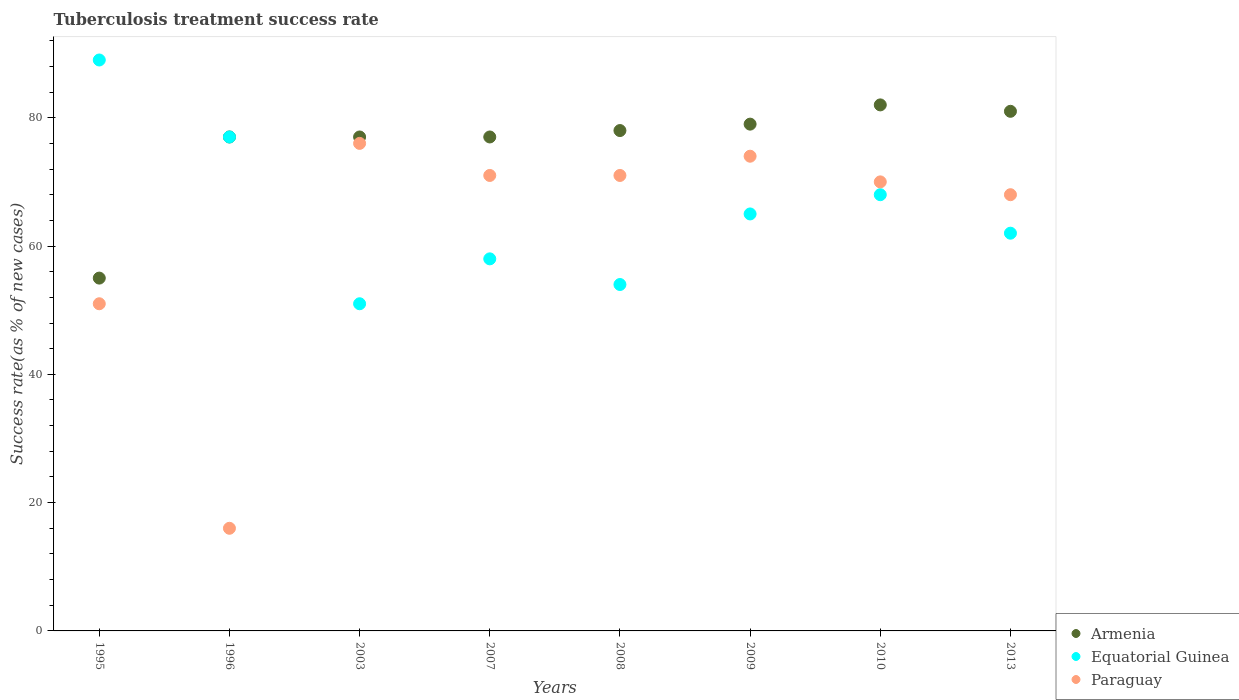How many different coloured dotlines are there?
Your response must be concise. 3. What is the tuberculosis treatment success rate in Paraguay in 2010?
Provide a succinct answer. 70. Across all years, what is the maximum tuberculosis treatment success rate in Armenia?
Your answer should be compact. 82. What is the total tuberculosis treatment success rate in Equatorial Guinea in the graph?
Your answer should be very brief. 524. What is the difference between the tuberculosis treatment success rate in Paraguay in 2003 and the tuberculosis treatment success rate in Equatorial Guinea in 1996?
Keep it short and to the point. -1. What is the average tuberculosis treatment success rate in Paraguay per year?
Provide a succinct answer. 62.12. What is the ratio of the tuberculosis treatment success rate in Equatorial Guinea in 2008 to that in 2009?
Provide a short and direct response. 0.83. Is the tuberculosis treatment success rate in Paraguay in 1996 less than that in 2008?
Ensure brevity in your answer.  Yes. Is the difference between the tuberculosis treatment success rate in Equatorial Guinea in 2008 and 2009 greater than the difference between the tuberculosis treatment success rate in Paraguay in 2008 and 2009?
Provide a short and direct response. No. What is the difference between the highest and the lowest tuberculosis treatment success rate in Paraguay?
Offer a terse response. 60. Is the sum of the tuberculosis treatment success rate in Equatorial Guinea in 1995 and 2008 greater than the maximum tuberculosis treatment success rate in Armenia across all years?
Provide a succinct answer. Yes. Does the tuberculosis treatment success rate in Paraguay monotonically increase over the years?
Give a very brief answer. No. How many dotlines are there?
Ensure brevity in your answer.  3. How many years are there in the graph?
Offer a very short reply. 8. What is the difference between two consecutive major ticks on the Y-axis?
Your answer should be compact. 20. Where does the legend appear in the graph?
Your answer should be very brief. Bottom right. How are the legend labels stacked?
Provide a succinct answer. Vertical. What is the title of the graph?
Your answer should be very brief. Tuberculosis treatment success rate. What is the label or title of the X-axis?
Ensure brevity in your answer.  Years. What is the label or title of the Y-axis?
Your answer should be compact. Success rate(as % of new cases). What is the Success rate(as % of new cases) of Armenia in 1995?
Your answer should be compact. 55. What is the Success rate(as % of new cases) of Equatorial Guinea in 1995?
Your answer should be compact. 89. What is the Success rate(as % of new cases) of Paraguay in 1995?
Your answer should be compact. 51. What is the Success rate(as % of new cases) in Equatorial Guinea in 2003?
Make the answer very short. 51. What is the Success rate(as % of new cases) in Armenia in 2007?
Keep it short and to the point. 77. What is the Success rate(as % of new cases) of Equatorial Guinea in 2007?
Make the answer very short. 58. What is the Success rate(as % of new cases) of Paraguay in 2007?
Your answer should be very brief. 71. What is the Success rate(as % of new cases) of Armenia in 2008?
Your answer should be compact. 78. What is the Success rate(as % of new cases) of Equatorial Guinea in 2008?
Your answer should be compact. 54. What is the Success rate(as % of new cases) of Paraguay in 2008?
Make the answer very short. 71. What is the Success rate(as % of new cases) in Armenia in 2009?
Provide a short and direct response. 79. What is the Success rate(as % of new cases) of Equatorial Guinea in 2009?
Your answer should be very brief. 65. What is the Success rate(as % of new cases) of Paraguay in 2009?
Provide a succinct answer. 74. What is the Success rate(as % of new cases) in Armenia in 2010?
Give a very brief answer. 82. What is the Success rate(as % of new cases) of Equatorial Guinea in 2010?
Make the answer very short. 68. What is the Success rate(as % of new cases) of Paraguay in 2010?
Keep it short and to the point. 70. What is the Success rate(as % of new cases) of Paraguay in 2013?
Give a very brief answer. 68. Across all years, what is the maximum Success rate(as % of new cases) of Equatorial Guinea?
Your response must be concise. 89. Across all years, what is the maximum Success rate(as % of new cases) in Paraguay?
Offer a very short reply. 76. Across all years, what is the minimum Success rate(as % of new cases) in Equatorial Guinea?
Ensure brevity in your answer.  51. What is the total Success rate(as % of new cases) in Armenia in the graph?
Offer a very short reply. 606. What is the total Success rate(as % of new cases) in Equatorial Guinea in the graph?
Give a very brief answer. 524. What is the total Success rate(as % of new cases) in Paraguay in the graph?
Ensure brevity in your answer.  497. What is the difference between the Success rate(as % of new cases) in Armenia in 1995 and that in 1996?
Give a very brief answer. -22. What is the difference between the Success rate(as % of new cases) in Equatorial Guinea in 1995 and that in 1996?
Your answer should be compact. 12. What is the difference between the Success rate(as % of new cases) in Equatorial Guinea in 1995 and that in 2003?
Offer a very short reply. 38. What is the difference between the Success rate(as % of new cases) in Paraguay in 1995 and that in 2003?
Offer a very short reply. -25. What is the difference between the Success rate(as % of new cases) of Armenia in 1995 and that in 2007?
Provide a succinct answer. -22. What is the difference between the Success rate(as % of new cases) of Equatorial Guinea in 1995 and that in 2007?
Provide a succinct answer. 31. What is the difference between the Success rate(as % of new cases) in Paraguay in 1995 and that in 2007?
Provide a short and direct response. -20. What is the difference between the Success rate(as % of new cases) in Paraguay in 1995 and that in 2008?
Give a very brief answer. -20. What is the difference between the Success rate(as % of new cases) of Armenia in 1995 and that in 2009?
Give a very brief answer. -24. What is the difference between the Success rate(as % of new cases) in Paraguay in 1995 and that in 2009?
Give a very brief answer. -23. What is the difference between the Success rate(as % of new cases) of Equatorial Guinea in 1995 and that in 2013?
Your answer should be very brief. 27. What is the difference between the Success rate(as % of new cases) in Paraguay in 1995 and that in 2013?
Keep it short and to the point. -17. What is the difference between the Success rate(as % of new cases) of Paraguay in 1996 and that in 2003?
Your response must be concise. -60. What is the difference between the Success rate(as % of new cases) in Paraguay in 1996 and that in 2007?
Ensure brevity in your answer.  -55. What is the difference between the Success rate(as % of new cases) in Equatorial Guinea in 1996 and that in 2008?
Your answer should be compact. 23. What is the difference between the Success rate(as % of new cases) of Paraguay in 1996 and that in 2008?
Make the answer very short. -55. What is the difference between the Success rate(as % of new cases) in Paraguay in 1996 and that in 2009?
Make the answer very short. -58. What is the difference between the Success rate(as % of new cases) in Equatorial Guinea in 1996 and that in 2010?
Offer a terse response. 9. What is the difference between the Success rate(as % of new cases) in Paraguay in 1996 and that in 2010?
Your answer should be compact. -54. What is the difference between the Success rate(as % of new cases) in Equatorial Guinea in 1996 and that in 2013?
Your answer should be very brief. 15. What is the difference between the Success rate(as % of new cases) of Paraguay in 1996 and that in 2013?
Give a very brief answer. -52. What is the difference between the Success rate(as % of new cases) of Armenia in 2003 and that in 2007?
Offer a terse response. 0. What is the difference between the Success rate(as % of new cases) in Equatorial Guinea in 2003 and that in 2007?
Ensure brevity in your answer.  -7. What is the difference between the Success rate(as % of new cases) of Paraguay in 2003 and that in 2007?
Offer a terse response. 5. What is the difference between the Success rate(as % of new cases) in Armenia in 2003 and that in 2008?
Provide a short and direct response. -1. What is the difference between the Success rate(as % of new cases) of Equatorial Guinea in 2003 and that in 2008?
Keep it short and to the point. -3. What is the difference between the Success rate(as % of new cases) in Paraguay in 2003 and that in 2008?
Keep it short and to the point. 5. What is the difference between the Success rate(as % of new cases) in Armenia in 2003 and that in 2009?
Ensure brevity in your answer.  -2. What is the difference between the Success rate(as % of new cases) in Equatorial Guinea in 2003 and that in 2009?
Give a very brief answer. -14. What is the difference between the Success rate(as % of new cases) of Armenia in 2003 and that in 2010?
Keep it short and to the point. -5. What is the difference between the Success rate(as % of new cases) in Equatorial Guinea in 2003 and that in 2010?
Give a very brief answer. -17. What is the difference between the Success rate(as % of new cases) in Armenia in 2003 and that in 2013?
Offer a very short reply. -4. What is the difference between the Success rate(as % of new cases) of Equatorial Guinea in 2003 and that in 2013?
Your answer should be compact. -11. What is the difference between the Success rate(as % of new cases) in Paraguay in 2003 and that in 2013?
Keep it short and to the point. 8. What is the difference between the Success rate(as % of new cases) of Paraguay in 2007 and that in 2008?
Offer a very short reply. 0. What is the difference between the Success rate(as % of new cases) in Equatorial Guinea in 2007 and that in 2009?
Offer a terse response. -7. What is the difference between the Success rate(as % of new cases) of Paraguay in 2007 and that in 2009?
Provide a succinct answer. -3. What is the difference between the Success rate(as % of new cases) in Armenia in 2007 and that in 2010?
Your response must be concise. -5. What is the difference between the Success rate(as % of new cases) of Equatorial Guinea in 2007 and that in 2010?
Give a very brief answer. -10. What is the difference between the Success rate(as % of new cases) in Armenia in 2007 and that in 2013?
Your answer should be very brief. -4. What is the difference between the Success rate(as % of new cases) in Equatorial Guinea in 2007 and that in 2013?
Make the answer very short. -4. What is the difference between the Success rate(as % of new cases) of Paraguay in 2007 and that in 2013?
Give a very brief answer. 3. What is the difference between the Success rate(as % of new cases) in Armenia in 2008 and that in 2009?
Offer a very short reply. -1. What is the difference between the Success rate(as % of new cases) in Equatorial Guinea in 2008 and that in 2009?
Keep it short and to the point. -11. What is the difference between the Success rate(as % of new cases) in Paraguay in 2008 and that in 2009?
Your answer should be compact. -3. What is the difference between the Success rate(as % of new cases) in Equatorial Guinea in 2008 and that in 2010?
Your answer should be compact. -14. What is the difference between the Success rate(as % of new cases) of Paraguay in 2008 and that in 2010?
Keep it short and to the point. 1. What is the difference between the Success rate(as % of new cases) of Equatorial Guinea in 2008 and that in 2013?
Give a very brief answer. -8. What is the difference between the Success rate(as % of new cases) in Equatorial Guinea in 2009 and that in 2010?
Make the answer very short. -3. What is the difference between the Success rate(as % of new cases) in Paraguay in 2010 and that in 2013?
Make the answer very short. 2. What is the difference between the Success rate(as % of new cases) of Armenia in 1995 and the Success rate(as % of new cases) of Equatorial Guinea in 1996?
Provide a short and direct response. -22. What is the difference between the Success rate(as % of new cases) of Armenia in 1995 and the Success rate(as % of new cases) of Equatorial Guinea in 2003?
Provide a short and direct response. 4. What is the difference between the Success rate(as % of new cases) of Armenia in 1995 and the Success rate(as % of new cases) of Paraguay in 2003?
Offer a very short reply. -21. What is the difference between the Success rate(as % of new cases) of Armenia in 1995 and the Success rate(as % of new cases) of Equatorial Guinea in 2007?
Ensure brevity in your answer.  -3. What is the difference between the Success rate(as % of new cases) of Equatorial Guinea in 1995 and the Success rate(as % of new cases) of Paraguay in 2008?
Give a very brief answer. 18. What is the difference between the Success rate(as % of new cases) in Armenia in 1995 and the Success rate(as % of new cases) in Equatorial Guinea in 2009?
Make the answer very short. -10. What is the difference between the Success rate(as % of new cases) in Armenia in 1995 and the Success rate(as % of new cases) in Equatorial Guinea in 2010?
Offer a terse response. -13. What is the difference between the Success rate(as % of new cases) of Equatorial Guinea in 1995 and the Success rate(as % of new cases) of Paraguay in 2010?
Your answer should be very brief. 19. What is the difference between the Success rate(as % of new cases) of Armenia in 1995 and the Success rate(as % of new cases) of Equatorial Guinea in 2013?
Keep it short and to the point. -7. What is the difference between the Success rate(as % of new cases) of Armenia in 1995 and the Success rate(as % of new cases) of Paraguay in 2013?
Offer a terse response. -13. What is the difference between the Success rate(as % of new cases) of Equatorial Guinea in 1995 and the Success rate(as % of new cases) of Paraguay in 2013?
Ensure brevity in your answer.  21. What is the difference between the Success rate(as % of new cases) in Armenia in 1996 and the Success rate(as % of new cases) in Equatorial Guinea in 2003?
Keep it short and to the point. 26. What is the difference between the Success rate(as % of new cases) in Armenia in 1996 and the Success rate(as % of new cases) in Paraguay in 2003?
Your response must be concise. 1. What is the difference between the Success rate(as % of new cases) in Armenia in 1996 and the Success rate(as % of new cases) in Equatorial Guinea in 2007?
Give a very brief answer. 19. What is the difference between the Success rate(as % of new cases) of Equatorial Guinea in 1996 and the Success rate(as % of new cases) of Paraguay in 2007?
Give a very brief answer. 6. What is the difference between the Success rate(as % of new cases) in Armenia in 1996 and the Success rate(as % of new cases) in Equatorial Guinea in 2008?
Provide a short and direct response. 23. What is the difference between the Success rate(as % of new cases) of Armenia in 1996 and the Success rate(as % of new cases) of Equatorial Guinea in 2009?
Provide a succinct answer. 12. What is the difference between the Success rate(as % of new cases) of Equatorial Guinea in 1996 and the Success rate(as % of new cases) of Paraguay in 2009?
Make the answer very short. 3. What is the difference between the Success rate(as % of new cases) in Armenia in 1996 and the Success rate(as % of new cases) in Equatorial Guinea in 2010?
Make the answer very short. 9. What is the difference between the Success rate(as % of new cases) of Equatorial Guinea in 1996 and the Success rate(as % of new cases) of Paraguay in 2013?
Your response must be concise. 9. What is the difference between the Success rate(as % of new cases) in Equatorial Guinea in 2003 and the Success rate(as % of new cases) in Paraguay in 2007?
Your response must be concise. -20. What is the difference between the Success rate(as % of new cases) of Armenia in 2003 and the Success rate(as % of new cases) of Paraguay in 2009?
Provide a short and direct response. 3. What is the difference between the Success rate(as % of new cases) in Armenia in 2003 and the Success rate(as % of new cases) in Equatorial Guinea in 2010?
Make the answer very short. 9. What is the difference between the Success rate(as % of new cases) in Armenia in 2003 and the Success rate(as % of new cases) in Paraguay in 2010?
Your response must be concise. 7. What is the difference between the Success rate(as % of new cases) of Equatorial Guinea in 2003 and the Success rate(as % of new cases) of Paraguay in 2010?
Ensure brevity in your answer.  -19. What is the difference between the Success rate(as % of new cases) of Equatorial Guinea in 2003 and the Success rate(as % of new cases) of Paraguay in 2013?
Make the answer very short. -17. What is the difference between the Success rate(as % of new cases) of Armenia in 2007 and the Success rate(as % of new cases) of Equatorial Guinea in 2009?
Provide a short and direct response. 12. What is the difference between the Success rate(as % of new cases) of Armenia in 2007 and the Success rate(as % of new cases) of Paraguay in 2009?
Ensure brevity in your answer.  3. What is the difference between the Success rate(as % of new cases) in Armenia in 2007 and the Success rate(as % of new cases) in Equatorial Guinea in 2010?
Make the answer very short. 9. What is the difference between the Success rate(as % of new cases) in Armenia in 2007 and the Success rate(as % of new cases) in Paraguay in 2010?
Ensure brevity in your answer.  7. What is the difference between the Success rate(as % of new cases) in Armenia in 2008 and the Success rate(as % of new cases) in Paraguay in 2009?
Provide a short and direct response. 4. What is the difference between the Success rate(as % of new cases) of Equatorial Guinea in 2008 and the Success rate(as % of new cases) of Paraguay in 2009?
Keep it short and to the point. -20. What is the difference between the Success rate(as % of new cases) of Armenia in 2008 and the Success rate(as % of new cases) of Equatorial Guinea in 2010?
Your response must be concise. 10. What is the difference between the Success rate(as % of new cases) of Armenia in 2008 and the Success rate(as % of new cases) of Paraguay in 2013?
Keep it short and to the point. 10. What is the difference between the Success rate(as % of new cases) in Equatorial Guinea in 2008 and the Success rate(as % of new cases) in Paraguay in 2013?
Ensure brevity in your answer.  -14. What is the difference between the Success rate(as % of new cases) in Armenia in 2009 and the Success rate(as % of new cases) in Equatorial Guinea in 2010?
Give a very brief answer. 11. What is the difference between the Success rate(as % of new cases) of Armenia in 2009 and the Success rate(as % of new cases) of Paraguay in 2013?
Provide a short and direct response. 11. What is the difference between the Success rate(as % of new cases) in Equatorial Guinea in 2009 and the Success rate(as % of new cases) in Paraguay in 2013?
Keep it short and to the point. -3. What is the average Success rate(as % of new cases) of Armenia per year?
Ensure brevity in your answer.  75.75. What is the average Success rate(as % of new cases) in Equatorial Guinea per year?
Your response must be concise. 65.5. What is the average Success rate(as % of new cases) of Paraguay per year?
Offer a very short reply. 62.12. In the year 1995, what is the difference between the Success rate(as % of new cases) in Armenia and Success rate(as % of new cases) in Equatorial Guinea?
Your response must be concise. -34. In the year 1995, what is the difference between the Success rate(as % of new cases) in Armenia and Success rate(as % of new cases) in Paraguay?
Keep it short and to the point. 4. In the year 1995, what is the difference between the Success rate(as % of new cases) of Equatorial Guinea and Success rate(as % of new cases) of Paraguay?
Keep it short and to the point. 38. In the year 1996, what is the difference between the Success rate(as % of new cases) of Armenia and Success rate(as % of new cases) of Equatorial Guinea?
Offer a very short reply. 0. In the year 2003, what is the difference between the Success rate(as % of new cases) in Armenia and Success rate(as % of new cases) in Paraguay?
Make the answer very short. 1. In the year 2003, what is the difference between the Success rate(as % of new cases) in Equatorial Guinea and Success rate(as % of new cases) in Paraguay?
Provide a short and direct response. -25. In the year 2007, what is the difference between the Success rate(as % of new cases) of Armenia and Success rate(as % of new cases) of Equatorial Guinea?
Give a very brief answer. 19. In the year 2008, what is the difference between the Success rate(as % of new cases) in Armenia and Success rate(as % of new cases) in Paraguay?
Your answer should be compact. 7. In the year 2008, what is the difference between the Success rate(as % of new cases) of Equatorial Guinea and Success rate(as % of new cases) of Paraguay?
Make the answer very short. -17. In the year 2009, what is the difference between the Success rate(as % of new cases) in Armenia and Success rate(as % of new cases) in Paraguay?
Offer a very short reply. 5. In the year 2010, what is the difference between the Success rate(as % of new cases) of Armenia and Success rate(as % of new cases) of Equatorial Guinea?
Your answer should be very brief. 14. In the year 2013, what is the difference between the Success rate(as % of new cases) in Equatorial Guinea and Success rate(as % of new cases) in Paraguay?
Provide a succinct answer. -6. What is the ratio of the Success rate(as % of new cases) in Armenia in 1995 to that in 1996?
Offer a terse response. 0.71. What is the ratio of the Success rate(as % of new cases) of Equatorial Guinea in 1995 to that in 1996?
Offer a very short reply. 1.16. What is the ratio of the Success rate(as % of new cases) in Paraguay in 1995 to that in 1996?
Your answer should be very brief. 3.19. What is the ratio of the Success rate(as % of new cases) of Armenia in 1995 to that in 2003?
Your response must be concise. 0.71. What is the ratio of the Success rate(as % of new cases) of Equatorial Guinea in 1995 to that in 2003?
Your answer should be very brief. 1.75. What is the ratio of the Success rate(as % of new cases) of Paraguay in 1995 to that in 2003?
Your answer should be very brief. 0.67. What is the ratio of the Success rate(as % of new cases) of Equatorial Guinea in 1995 to that in 2007?
Keep it short and to the point. 1.53. What is the ratio of the Success rate(as % of new cases) of Paraguay in 1995 to that in 2007?
Your answer should be very brief. 0.72. What is the ratio of the Success rate(as % of new cases) of Armenia in 1995 to that in 2008?
Offer a terse response. 0.71. What is the ratio of the Success rate(as % of new cases) of Equatorial Guinea in 1995 to that in 2008?
Provide a short and direct response. 1.65. What is the ratio of the Success rate(as % of new cases) of Paraguay in 1995 to that in 2008?
Your answer should be compact. 0.72. What is the ratio of the Success rate(as % of new cases) of Armenia in 1995 to that in 2009?
Ensure brevity in your answer.  0.7. What is the ratio of the Success rate(as % of new cases) of Equatorial Guinea in 1995 to that in 2009?
Provide a short and direct response. 1.37. What is the ratio of the Success rate(as % of new cases) in Paraguay in 1995 to that in 2009?
Provide a succinct answer. 0.69. What is the ratio of the Success rate(as % of new cases) of Armenia in 1995 to that in 2010?
Provide a succinct answer. 0.67. What is the ratio of the Success rate(as % of new cases) of Equatorial Guinea in 1995 to that in 2010?
Offer a very short reply. 1.31. What is the ratio of the Success rate(as % of new cases) in Paraguay in 1995 to that in 2010?
Your answer should be very brief. 0.73. What is the ratio of the Success rate(as % of new cases) in Armenia in 1995 to that in 2013?
Make the answer very short. 0.68. What is the ratio of the Success rate(as % of new cases) in Equatorial Guinea in 1995 to that in 2013?
Offer a very short reply. 1.44. What is the ratio of the Success rate(as % of new cases) in Paraguay in 1995 to that in 2013?
Make the answer very short. 0.75. What is the ratio of the Success rate(as % of new cases) in Armenia in 1996 to that in 2003?
Give a very brief answer. 1. What is the ratio of the Success rate(as % of new cases) in Equatorial Guinea in 1996 to that in 2003?
Ensure brevity in your answer.  1.51. What is the ratio of the Success rate(as % of new cases) in Paraguay in 1996 to that in 2003?
Offer a terse response. 0.21. What is the ratio of the Success rate(as % of new cases) of Equatorial Guinea in 1996 to that in 2007?
Offer a very short reply. 1.33. What is the ratio of the Success rate(as % of new cases) in Paraguay in 1996 to that in 2007?
Provide a short and direct response. 0.23. What is the ratio of the Success rate(as % of new cases) in Armenia in 1996 to that in 2008?
Keep it short and to the point. 0.99. What is the ratio of the Success rate(as % of new cases) of Equatorial Guinea in 1996 to that in 2008?
Offer a very short reply. 1.43. What is the ratio of the Success rate(as % of new cases) in Paraguay in 1996 to that in 2008?
Your answer should be compact. 0.23. What is the ratio of the Success rate(as % of new cases) of Armenia in 1996 to that in 2009?
Provide a succinct answer. 0.97. What is the ratio of the Success rate(as % of new cases) in Equatorial Guinea in 1996 to that in 2009?
Make the answer very short. 1.18. What is the ratio of the Success rate(as % of new cases) in Paraguay in 1996 to that in 2009?
Offer a very short reply. 0.22. What is the ratio of the Success rate(as % of new cases) in Armenia in 1996 to that in 2010?
Offer a very short reply. 0.94. What is the ratio of the Success rate(as % of new cases) in Equatorial Guinea in 1996 to that in 2010?
Your response must be concise. 1.13. What is the ratio of the Success rate(as % of new cases) of Paraguay in 1996 to that in 2010?
Your response must be concise. 0.23. What is the ratio of the Success rate(as % of new cases) of Armenia in 1996 to that in 2013?
Your answer should be compact. 0.95. What is the ratio of the Success rate(as % of new cases) of Equatorial Guinea in 1996 to that in 2013?
Make the answer very short. 1.24. What is the ratio of the Success rate(as % of new cases) of Paraguay in 1996 to that in 2013?
Make the answer very short. 0.24. What is the ratio of the Success rate(as % of new cases) in Equatorial Guinea in 2003 to that in 2007?
Your response must be concise. 0.88. What is the ratio of the Success rate(as % of new cases) of Paraguay in 2003 to that in 2007?
Keep it short and to the point. 1.07. What is the ratio of the Success rate(as % of new cases) of Armenia in 2003 to that in 2008?
Offer a very short reply. 0.99. What is the ratio of the Success rate(as % of new cases) of Equatorial Guinea in 2003 to that in 2008?
Provide a short and direct response. 0.94. What is the ratio of the Success rate(as % of new cases) in Paraguay in 2003 to that in 2008?
Give a very brief answer. 1.07. What is the ratio of the Success rate(as % of new cases) of Armenia in 2003 to that in 2009?
Offer a very short reply. 0.97. What is the ratio of the Success rate(as % of new cases) in Equatorial Guinea in 2003 to that in 2009?
Keep it short and to the point. 0.78. What is the ratio of the Success rate(as % of new cases) of Paraguay in 2003 to that in 2009?
Ensure brevity in your answer.  1.03. What is the ratio of the Success rate(as % of new cases) in Armenia in 2003 to that in 2010?
Your answer should be compact. 0.94. What is the ratio of the Success rate(as % of new cases) of Equatorial Guinea in 2003 to that in 2010?
Offer a very short reply. 0.75. What is the ratio of the Success rate(as % of new cases) in Paraguay in 2003 to that in 2010?
Ensure brevity in your answer.  1.09. What is the ratio of the Success rate(as % of new cases) of Armenia in 2003 to that in 2013?
Offer a terse response. 0.95. What is the ratio of the Success rate(as % of new cases) in Equatorial Guinea in 2003 to that in 2013?
Make the answer very short. 0.82. What is the ratio of the Success rate(as % of new cases) of Paraguay in 2003 to that in 2013?
Keep it short and to the point. 1.12. What is the ratio of the Success rate(as % of new cases) of Armenia in 2007 to that in 2008?
Your answer should be compact. 0.99. What is the ratio of the Success rate(as % of new cases) in Equatorial Guinea in 2007 to that in 2008?
Provide a short and direct response. 1.07. What is the ratio of the Success rate(as % of new cases) of Paraguay in 2007 to that in 2008?
Provide a succinct answer. 1. What is the ratio of the Success rate(as % of new cases) in Armenia in 2007 to that in 2009?
Your answer should be very brief. 0.97. What is the ratio of the Success rate(as % of new cases) of Equatorial Guinea in 2007 to that in 2009?
Your answer should be very brief. 0.89. What is the ratio of the Success rate(as % of new cases) of Paraguay in 2007 to that in 2009?
Ensure brevity in your answer.  0.96. What is the ratio of the Success rate(as % of new cases) of Armenia in 2007 to that in 2010?
Offer a very short reply. 0.94. What is the ratio of the Success rate(as % of new cases) of Equatorial Guinea in 2007 to that in 2010?
Ensure brevity in your answer.  0.85. What is the ratio of the Success rate(as % of new cases) of Paraguay in 2007 to that in 2010?
Your response must be concise. 1.01. What is the ratio of the Success rate(as % of new cases) of Armenia in 2007 to that in 2013?
Your answer should be very brief. 0.95. What is the ratio of the Success rate(as % of new cases) of Equatorial Guinea in 2007 to that in 2013?
Your answer should be very brief. 0.94. What is the ratio of the Success rate(as % of new cases) in Paraguay in 2007 to that in 2013?
Your answer should be compact. 1.04. What is the ratio of the Success rate(as % of new cases) in Armenia in 2008 to that in 2009?
Your answer should be compact. 0.99. What is the ratio of the Success rate(as % of new cases) of Equatorial Guinea in 2008 to that in 2009?
Make the answer very short. 0.83. What is the ratio of the Success rate(as % of new cases) of Paraguay in 2008 to that in 2009?
Offer a terse response. 0.96. What is the ratio of the Success rate(as % of new cases) in Armenia in 2008 to that in 2010?
Provide a succinct answer. 0.95. What is the ratio of the Success rate(as % of new cases) of Equatorial Guinea in 2008 to that in 2010?
Your answer should be very brief. 0.79. What is the ratio of the Success rate(as % of new cases) of Paraguay in 2008 to that in 2010?
Make the answer very short. 1.01. What is the ratio of the Success rate(as % of new cases) of Armenia in 2008 to that in 2013?
Offer a very short reply. 0.96. What is the ratio of the Success rate(as % of new cases) of Equatorial Guinea in 2008 to that in 2013?
Ensure brevity in your answer.  0.87. What is the ratio of the Success rate(as % of new cases) in Paraguay in 2008 to that in 2013?
Give a very brief answer. 1.04. What is the ratio of the Success rate(as % of new cases) in Armenia in 2009 to that in 2010?
Offer a terse response. 0.96. What is the ratio of the Success rate(as % of new cases) of Equatorial Guinea in 2009 to that in 2010?
Offer a very short reply. 0.96. What is the ratio of the Success rate(as % of new cases) in Paraguay in 2009 to that in 2010?
Your response must be concise. 1.06. What is the ratio of the Success rate(as % of new cases) in Armenia in 2009 to that in 2013?
Make the answer very short. 0.98. What is the ratio of the Success rate(as % of new cases) in Equatorial Guinea in 2009 to that in 2013?
Your answer should be very brief. 1.05. What is the ratio of the Success rate(as % of new cases) of Paraguay in 2009 to that in 2013?
Offer a very short reply. 1.09. What is the ratio of the Success rate(as % of new cases) of Armenia in 2010 to that in 2013?
Offer a very short reply. 1.01. What is the ratio of the Success rate(as % of new cases) in Equatorial Guinea in 2010 to that in 2013?
Give a very brief answer. 1.1. What is the ratio of the Success rate(as % of new cases) of Paraguay in 2010 to that in 2013?
Your answer should be very brief. 1.03. What is the difference between the highest and the second highest Success rate(as % of new cases) in Armenia?
Keep it short and to the point. 1. What is the difference between the highest and the lowest Success rate(as % of new cases) of Armenia?
Keep it short and to the point. 27. What is the difference between the highest and the lowest Success rate(as % of new cases) in Equatorial Guinea?
Offer a very short reply. 38. What is the difference between the highest and the lowest Success rate(as % of new cases) of Paraguay?
Offer a very short reply. 60. 